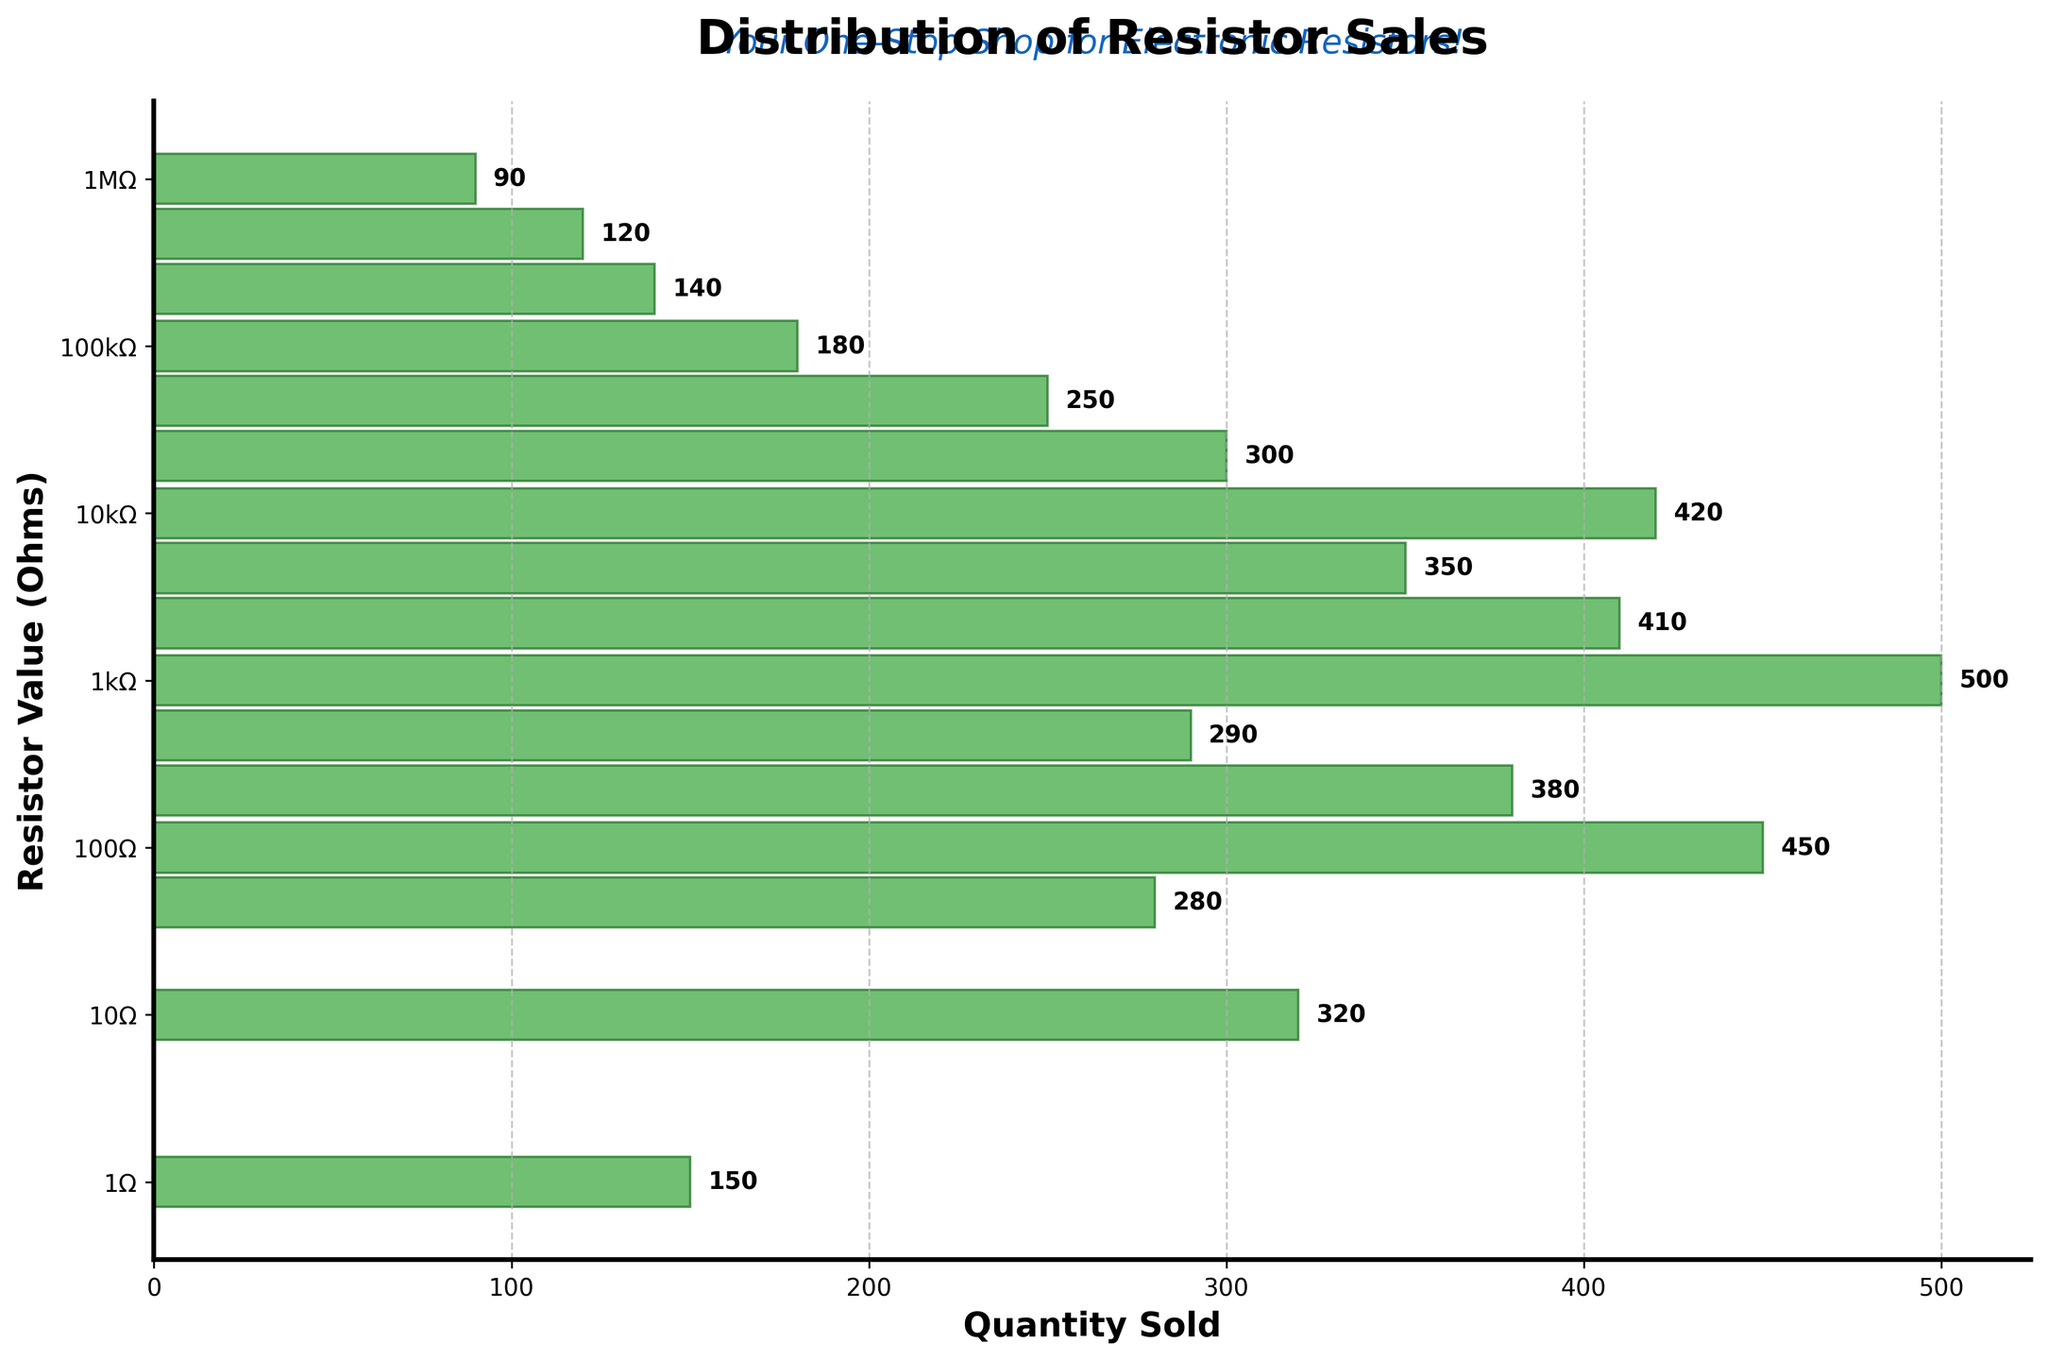What is the title of the plot? The title of the plot is displayed at the top and it reads 'Distribution of Resistor Sales'.
Answer: Distribution of Resistor Sales How many resistor value categories are represented in the plot? The plot shows bars corresponding to different resistor values on the y-axis. By counting the separate bars, there are 16 categories.
Answer: 16 Which resistor value had the highest quantity sold? By observing the length of the bars, the resistor value with the longest bar indicates the highest quantity sold. The longest bar is at 1000 ohms, with 500 units sold.
Answer: 1000 ohms What is the quantity sold for the resistor value of 47 ohms? Locate the bar corresponding to 47 ohms on the y-axis. The label next to the bar indicates the quantity sold, which is 280 units.
Answer: 280 Does the quantity sold generally increase or decrease as the resistor value increases? By observing the trend of the bar lengths as you move from the lower to the higher resistor values on the y-axis, the quantities sold generally decrease.
Answer: Decrease How many resistors values exceed a sales quantity of 400 units each? Examine the bars to identify those with a length extending beyond the 400 mark on the x-axis. The resistor values that meet this criterion are 100, 1000, and 10000 ohms. There are 3 of them.
Answer: 3 What is the minimum quantity sold among all resistor values? The shortest bar indicates the minimum quantity sold. The bar at 1 megohm (1000000 ohms) represents the lowest quantity, which is 90 units.
Answer: 90 If you sum the quantities sold for 1 ohm, 10 ohms, and 47 ohms resistors, what is the total? Adding the quantities sold of these resistors: 150 (1 ohm) + 320 (10 ohms) + 280 (47 ohms) results in a total of 750 units.
Answer: 750 Compare the quantity sold of 2200 ohms and 470 ohms resistors. Which one is higher, and by how much? Locate the bars for 2200 ohms (410 units) and 470 ohms (290 units). The difference is 410 - 290, equal to 120 units. The 2200 ohms resistor is higher by 120 units.
Answer: 2200 ohms by 120 units 